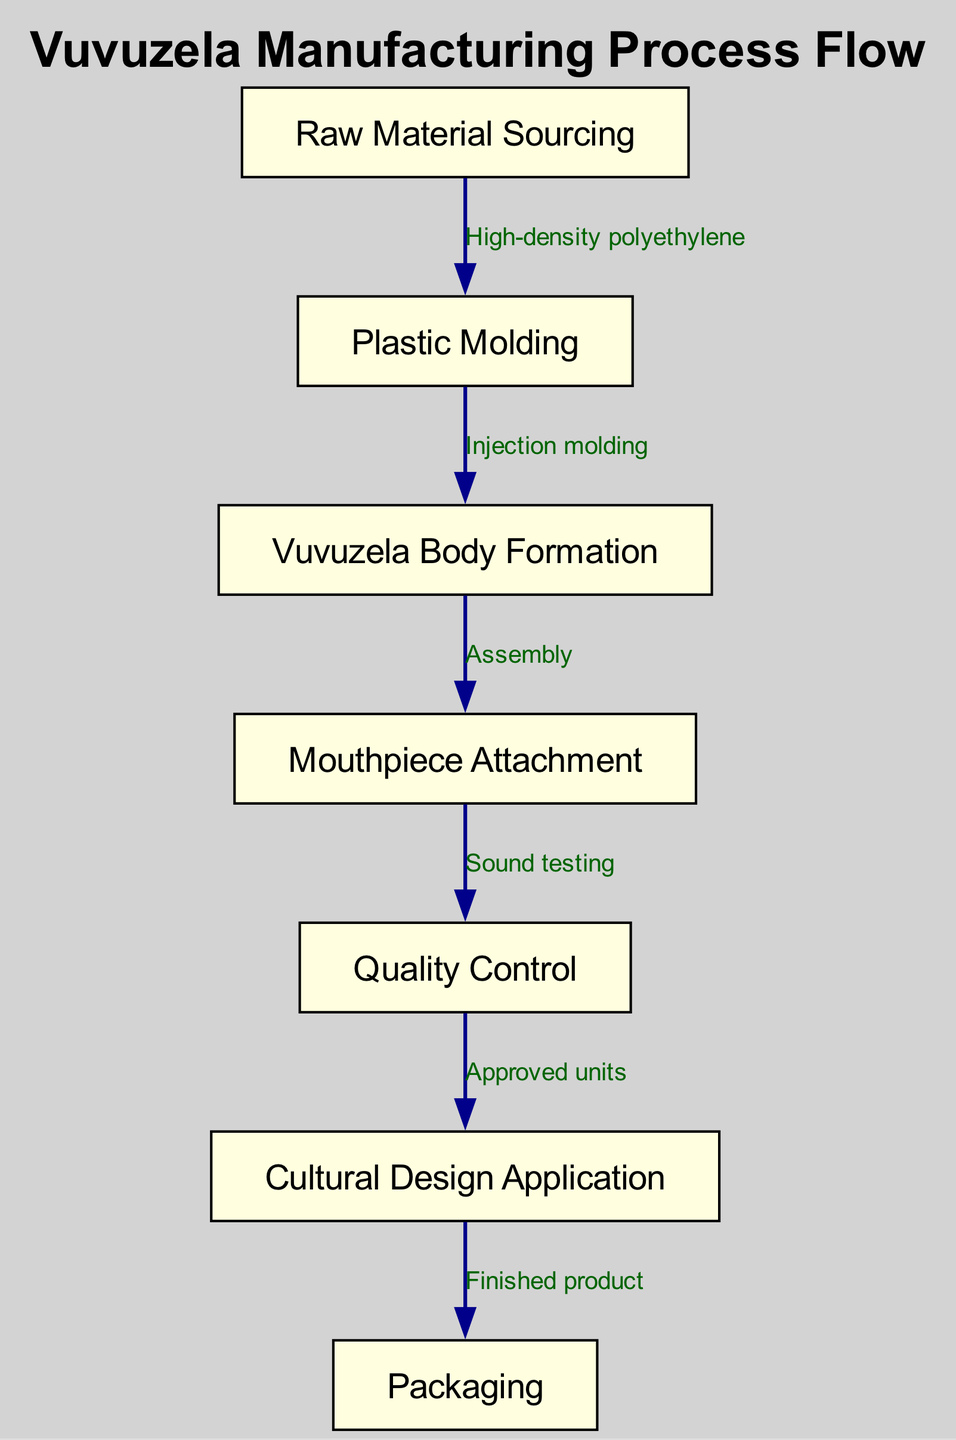What is the first step in the manufacturing process? The first step is indicated as "Raw Material Sourcing" in the diagram, which shows that this is the starting point for the vuvuzela manufacturing process.
Answer: Raw Material Sourcing How many nodes are represented in the diagram? By counting the distinct labeled processes in the diagram, we can identify that there are a total of seven nodes listed.
Answer: Seven Which material is used in the second step? The second step shown in the diagram is "Plastic Molding," and it specifies "High-density polyethylene" as the material used for this process.
Answer: High-density polyethylene What is the final step in the manufacturing process? The final step is labeled "Packaging," indicating that once the vuvuzela is completed, it goes to packaging.
Answer: Packaging What process follows the Quality Control step? From the diagram, after "Quality Control," the next step is indicated as "Cultural Design Application," which means that approved units proceed to this stage.
Answer: Cultural Design Application How are the vuvuzela body and mouthpiece connected? The connection between the processes "Vuvuzela Body Formation" and "Mouthpiece Attachment" is through the step labeled "Assembly," which shows that this is how the two components are joined.
Answer: Assembly What is the relationship between Quality Control and Cultural Design Application? The diagram indicates that the "Quality Control" step leads to the "Cultural Design Application," and it specifies that only approved units advance to this stage, showing a dependency on the quality assurance outcome.
Answer: Approved units How does sound testing relate to the mouthpiece? The connection is described by the edge from "Mouthpiece Attachment" to "Quality Control," indicating that after attaching the mouthpiece, sound testing occurs to ensure quality before proceeding.
Answer: Sound testing What is the process of making the vuvuzela body? The process of making the vuvuzela body is denoted as "Vuvuzela Body Formation," which occurs after the plastic molding step using injection molding.
Answer: Vuvuzela Body Formation 